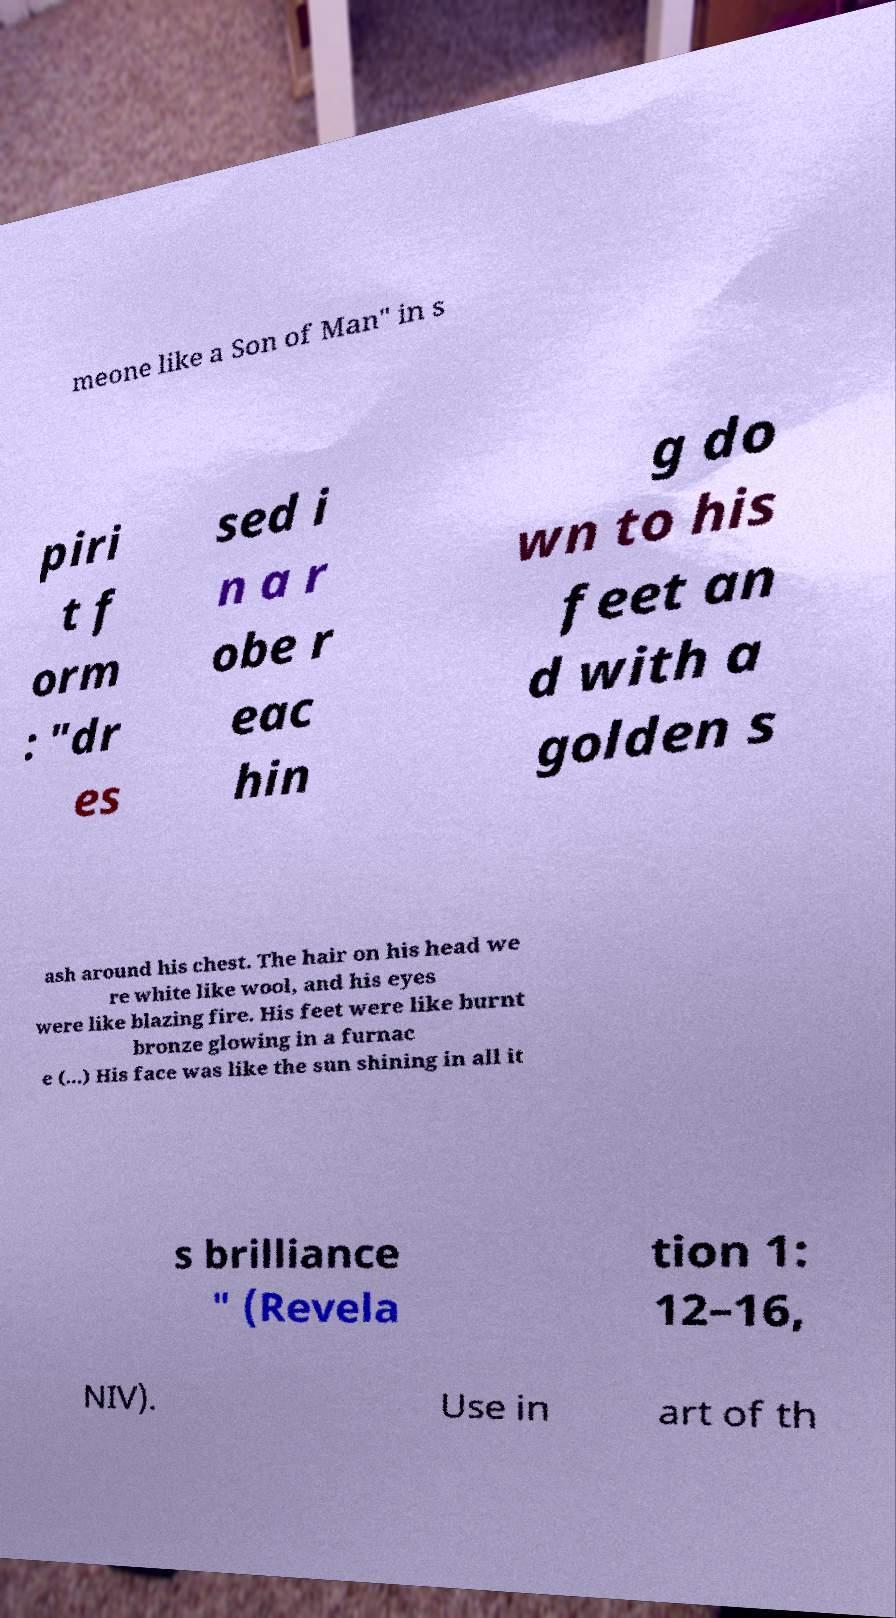For documentation purposes, I need the text within this image transcribed. Could you provide that? meone like a Son of Man" in s piri t f orm : "dr es sed i n a r obe r eac hin g do wn to his feet an d with a golden s ash around his chest. The hair on his head we re white like wool, and his eyes were like blazing fire. His feet were like burnt bronze glowing in a furnac e (...) His face was like the sun shining in all it s brilliance " (Revela tion 1: 12–16, NIV). Use in art of th 